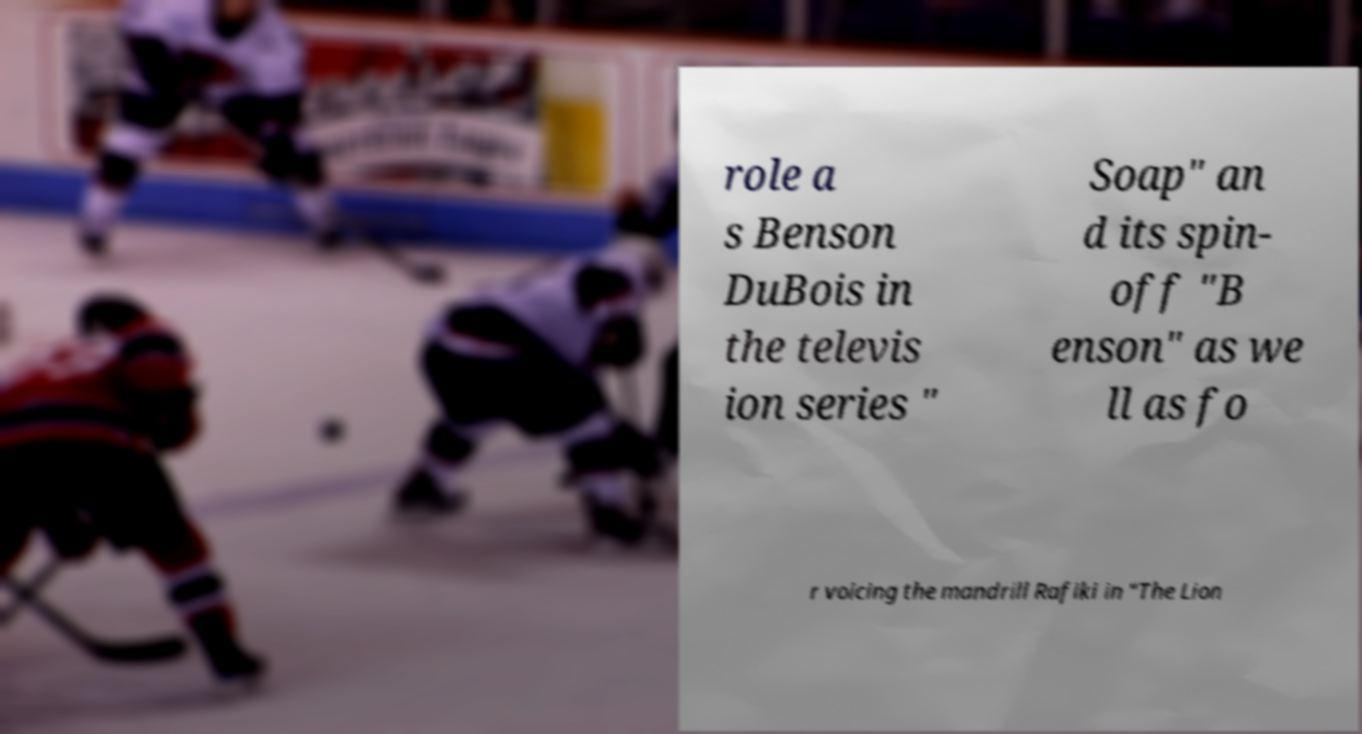Can you read and provide the text displayed in the image?This photo seems to have some interesting text. Can you extract and type it out for me? role a s Benson DuBois in the televis ion series " Soap" an d its spin- off "B enson" as we ll as fo r voicing the mandrill Rafiki in "The Lion 